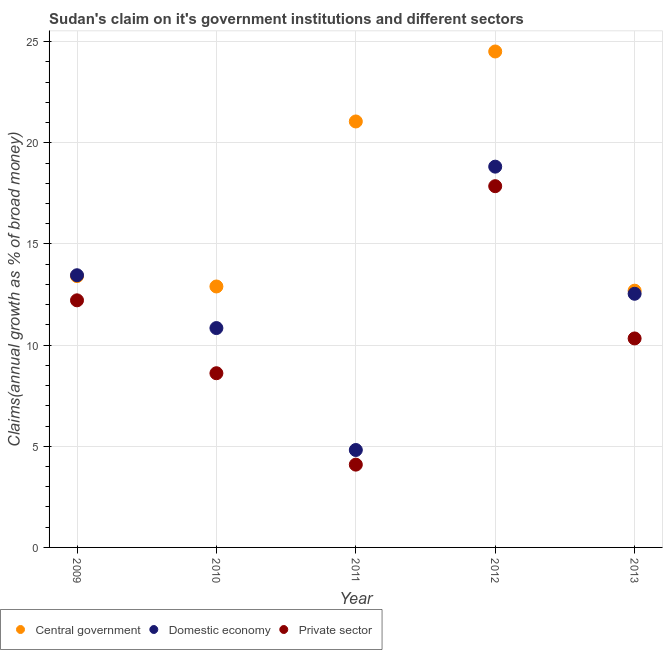Is the number of dotlines equal to the number of legend labels?
Your answer should be very brief. Yes. What is the percentage of claim on the central government in 2010?
Offer a very short reply. 12.9. Across all years, what is the maximum percentage of claim on the central government?
Ensure brevity in your answer.  24.51. Across all years, what is the minimum percentage of claim on the private sector?
Provide a succinct answer. 4.09. In which year was the percentage of claim on the central government minimum?
Your answer should be compact. 2013. What is the total percentage of claim on the private sector in the graph?
Your answer should be compact. 53.1. What is the difference between the percentage of claim on the private sector in 2009 and that in 2013?
Your answer should be very brief. 1.88. What is the difference between the percentage of claim on the central government in 2013 and the percentage of claim on the private sector in 2009?
Offer a very short reply. 0.48. What is the average percentage of claim on the private sector per year?
Offer a very short reply. 10.62. In the year 2013, what is the difference between the percentage of claim on the central government and percentage of claim on the domestic economy?
Keep it short and to the point. 0.15. What is the ratio of the percentage of claim on the central government in 2012 to that in 2013?
Ensure brevity in your answer.  1.93. Is the percentage of claim on the central government in 2009 less than that in 2012?
Ensure brevity in your answer.  Yes. Is the difference between the percentage of claim on the central government in 2010 and 2013 greater than the difference between the percentage of claim on the domestic economy in 2010 and 2013?
Offer a very short reply. Yes. What is the difference between the highest and the second highest percentage of claim on the domestic economy?
Your answer should be very brief. 5.37. What is the difference between the highest and the lowest percentage of claim on the central government?
Provide a succinct answer. 11.82. Is the sum of the percentage of claim on the central government in 2012 and 2013 greater than the maximum percentage of claim on the domestic economy across all years?
Your response must be concise. Yes. Is it the case that in every year, the sum of the percentage of claim on the central government and percentage of claim on the domestic economy is greater than the percentage of claim on the private sector?
Your answer should be compact. Yes. Does the percentage of claim on the domestic economy monotonically increase over the years?
Your answer should be very brief. No. Is the percentage of claim on the private sector strictly less than the percentage of claim on the domestic economy over the years?
Your answer should be compact. Yes. How many years are there in the graph?
Your answer should be compact. 5. What is the difference between two consecutive major ticks on the Y-axis?
Give a very brief answer. 5. Does the graph contain any zero values?
Your answer should be very brief. No. How are the legend labels stacked?
Make the answer very short. Horizontal. What is the title of the graph?
Your answer should be compact. Sudan's claim on it's government institutions and different sectors. What is the label or title of the Y-axis?
Offer a terse response. Claims(annual growth as % of broad money). What is the Claims(annual growth as % of broad money) of Central government in 2009?
Provide a short and direct response. 13.41. What is the Claims(annual growth as % of broad money) in Domestic economy in 2009?
Offer a very short reply. 13.45. What is the Claims(annual growth as % of broad money) of Private sector in 2009?
Ensure brevity in your answer.  12.21. What is the Claims(annual growth as % of broad money) in Central government in 2010?
Provide a succinct answer. 12.9. What is the Claims(annual growth as % of broad money) in Domestic economy in 2010?
Your response must be concise. 10.84. What is the Claims(annual growth as % of broad money) of Private sector in 2010?
Keep it short and to the point. 8.61. What is the Claims(annual growth as % of broad money) in Central government in 2011?
Provide a short and direct response. 21.05. What is the Claims(annual growth as % of broad money) of Domestic economy in 2011?
Provide a succinct answer. 4.82. What is the Claims(annual growth as % of broad money) of Private sector in 2011?
Keep it short and to the point. 4.09. What is the Claims(annual growth as % of broad money) of Central government in 2012?
Provide a succinct answer. 24.51. What is the Claims(annual growth as % of broad money) of Domestic economy in 2012?
Offer a very short reply. 18.82. What is the Claims(annual growth as % of broad money) of Private sector in 2012?
Your answer should be very brief. 17.85. What is the Claims(annual growth as % of broad money) of Central government in 2013?
Offer a terse response. 12.69. What is the Claims(annual growth as % of broad money) in Domestic economy in 2013?
Your answer should be compact. 12.54. What is the Claims(annual growth as % of broad money) of Private sector in 2013?
Provide a short and direct response. 10.33. Across all years, what is the maximum Claims(annual growth as % of broad money) of Central government?
Offer a terse response. 24.51. Across all years, what is the maximum Claims(annual growth as % of broad money) of Domestic economy?
Keep it short and to the point. 18.82. Across all years, what is the maximum Claims(annual growth as % of broad money) in Private sector?
Your answer should be compact. 17.85. Across all years, what is the minimum Claims(annual growth as % of broad money) of Central government?
Keep it short and to the point. 12.69. Across all years, what is the minimum Claims(annual growth as % of broad money) in Domestic economy?
Offer a terse response. 4.82. Across all years, what is the minimum Claims(annual growth as % of broad money) in Private sector?
Give a very brief answer. 4.09. What is the total Claims(annual growth as % of broad money) of Central government in the graph?
Ensure brevity in your answer.  84.56. What is the total Claims(annual growth as % of broad money) in Domestic economy in the graph?
Your answer should be compact. 60.47. What is the total Claims(annual growth as % of broad money) in Private sector in the graph?
Provide a succinct answer. 53.1. What is the difference between the Claims(annual growth as % of broad money) in Central government in 2009 and that in 2010?
Ensure brevity in your answer.  0.51. What is the difference between the Claims(annual growth as % of broad money) of Domestic economy in 2009 and that in 2010?
Keep it short and to the point. 2.61. What is the difference between the Claims(annual growth as % of broad money) in Private sector in 2009 and that in 2010?
Ensure brevity in your answer.  3.6. What is the difference between the Claims(annual growth as % of broad money) in Central government in 2009 and that in 2011?
Ensure brevity in your answer.  -7.64. What is the difference between the Claims(annual growth as % of broad money) in Domestic economy in 2009 and that in 2011?
Provide a succinct answer. 8.64. What is the difference between the Claims(annual growth as % of broad money) of Private sector in 2009 and that in 2011?
Provide a succinct answer. 8.12. What is the difference between the Claims(annual growth as % of broad money) of Central government in 2009 and that in 2012?
Make the answer very short. -11.1. What is the difference between the Claims(annual growth as % of broad money) in Domestic economy in 2009 and that in 2012?
Offer a very short reply. -5.37. What is the difference between the Claims(annual growth as % of broad money) of Private sector in 2009 and that in 2012?
Provide a succinct answer. -5.64. What is the difference between the Claims(annual growth as % of broad money) of Central government in 2009 and that in 2013?
Your response must be concise. 0.72. What is the difference between the Claims(annual growth as % of broad money) of Domestic economy in 2009 and that in 2013?
Offer a very short reply. 0.92. What is the difference between the Claims(annual growth as % of broad money) in Private sector in 2009 and that in 2013?
Provide a succinct answer. 1.88. What is the difference between the Claims(annual growth as % of broad money) in Central government in 2010 and that in 2011?
Keep it short and to the point. -8.16. What is the difference between the Claims(annual growth as % of broad money) of Domestic economy in 2010 and that in 2011?
Your response must be concise. 6.03. What is the difference between the Claims(annual growth as % of broad money) in Private sector in 2010 and that in 2011?
Give a very brief answer. 4.52. What is the difference between the Claims(annual growth as % of broad money) of Central government in 2010 and that in 2012?
Offer a very short reply. -11.61. What is the difference between the Claims(annual growth as % of broad money) of Domestic economy in 2010 and that in 2012?
Offer a very short reply. -7.98. What is the difference between the Claims(annual growth as % of broad money) in Private sector in 2010 and that in 2012?
Offer a terse response. -9.24. What is the difference between the Claims(annual growth as % of broad money) of Central government in 2010 and that in 2013?
Make the answer very short. 0.21. What is the difference between the Claims(annual growth as % of broad money) of Domestic economy in 2010 and that in 2013?
Your response must be concise. -1.69. What is the difference between the Claims(annual growth as % of broad money) in Private sector in 2010 and that in 2013?
Your answer should be compact. -1.72. What is the difference between the Claims(annual growth as % of broad money) in Central government in 2011 and that in 2012?
Provide a succinct answer. -3.46. What is the difference between the Claims(annual growth as % of broad money) in Domestic economy in 2011 and that in 2012?
Provide a short and direct response. -14. What is the difference between the Claims(annual growth as % of broad money) of Private sector in 2011 and that in 2012?
Your answer should be compact. -13.76. What is the difference between the Claims(annual growth as % of broad money) of Central government in 2011 and that in 2013?
Make the answer very short. 8.36. What is the difference between the Claims(annual growth as % of broad money) in Domestic economy in 2011 and that in 2013?
Your answer should be very brief. -7.72. What is the difference between the Claims(annual growth as % of broad money) in Private sector in 2011 and that in 2013?
Your response must be concise. -6.24. What is the difference between the Claims(annual growth as % of broad money) in Central government in 2012 and that in 2013?
Offer a terse response. 11.82. What is the difference between the Claims(annual growth as % of broad money) of Domestic economy in 2012 and that in 2013?
Your response must be concise. 6.28. What is the difference between the Claims(annual growth as % of broad money) in Private sector in 2012 and that in 2013?
Offer a terse response. 7.53. What is the difference between the Claims(annual growth as % of broad money) of Central government in 2009 and the Claims(annual growth as % of broad money) of Domestic economy in 2010?
Your response must be concise. 2.57. What is the difference between the Claims(annual growth as % of broad money) in Central government in 2009 and the Claims(annual growth as % of broad money) in Private sector in 2010?
Offer a terse response. 4.8. What is the difference between the Claims(annual growth as % of broad money) of Domestic economy in 2009 and the Claims(annual growth as % of broad money) of Private sector in 2010?
Make the answer very short. 4.84. What is the difference between the Claims(annual growth as % of broad money) of Central government in 2009 and the Claims(annual growth as % of broad money) of Domestic economy in 2011?
Ensure brevity in your answer.  8.59. What is the difference between the Claims(annual growth as % of broad money) in Central government in 2009 and the Claims(annual growth as % of broad money) in Private sector in 2011?
Provide a short and direct response. 9.32. What is the difference between the Claims(annual growth as % of broad money) in Domestic economy in 2009 and the Claims(annual growth as % of broad money) in Private sector in 2011?
Provide a succinct answer. 9.36. What is the difference between the Claims(annual growth as % of broad money) of Central government in 2009 and the Claims(annual growth as % of broad money) of Domestic economy in 2012?
Your answer should be compact. -5.41. What is the difference between the Claims(annual growth as % of broad money) in Central government in 2009 and the Claims(annual growth as % of broad money) in Private sector in 2012?
Make the answer very short. -4.45. What is the difference between the Claims(annual growth as % of broad money) in Domestic economy in 2009 and the Claims(annual growth as % of broad money) in Private sector in 2012?
Make the answer very short. -4.4. What is the difference between the Claims(annual growth as % of broad money) of Central government in 2009 and the Claims(annual growth as % of broad money) of Domestic economy in 2013?
Offer a very short reply. 0.87. What is the difference between the Claims(annual growth as % of broad money) in Central government in 2009 and the Claims(annual growth as % of broad money) in Private sector in 2013?
Offer a very short reply. 3.08. What is the difference between the Claims(annual growth as % of broad money) in Domestic economy in 2009 and the Claims(annual growth as % of broad money) in Private sector in 2013?
Provide a succinct answer. 3.12. What is the difference between the Claims(annual growth as % of broad money) of Central government in 2010 and the Claims(annual growth as % of broad money) of Domestic economy in 2011?
Give a very brief answer. 8.08. What is the difference between the Claims(annual growth as % of broad money) of Central government in 2010 and the Claims(annual growth as % of broad money) of Private sector in 2011?
Your answer should be very brief. 8.81. What is the difference between the Claims(annual growth as % of broad money) in Domestic economy in 2010 and the Claims(annual growth as % of broad money) in Private sector in 2011?
Give a very brief answer. 6.75. What is the difference between the Claims(annual growth as % of broad money) in Central government in 2010 and the Claims(annual growth as % of broad money) in Domestic economy in 2012?
Your answer should be compact. -5.92. What is the difference between the Claims(annual growth as % of broad money) in Central government in 2010 and the Claims(annual growth as % of broad money) in Private sector in 2012?
Your answer should be compact. -4.96. What is the difference between the Claims(annual growth as % of broad money) in Domestic economy in 2010 and the Claims(annual growth as % of broad money) in Private sector in 2012?
Ensure brevity in your answer.  -7.01. What is the difference between the Claims(annual growth as % of broad money) in Central government in 2010 and the Claims(annual growth as % of broad money) in Domestic economy in 2013?
Keep it short and to the point. 0.36. What is the difference between the Claims(annual growth as % of broad money) in Central government in 2010 and the Claims(annual growth as % of broad money) in Private sector in 2013?
Ensure brevity in your answer.  2.57. What is the difference between the Claims(annual growth as % of broad money) of Domestic economy in 2010 and the Claims(annual growth as % of broad money) of Private sector in 2013?
Your answer should be compact. 0.51. What is the difference between the Claims(annual growth as % of broad money) in Central government in 2011 and the Claims(annual growth as % of broad money) in Domestic economy in 2012?
Your answer should be compact. 2.23. What is the difference between the Claims(annual growth as % of broad money) in Central government in 2011 and the Claims(annual growth as % of broad money) in Private sector in 2012?
Your response must be concise. 3.2. What is the difference between the Claims(annual growth as % of broad money) of Domestic economy in 2011 and the Claims(annual growth as % of broad money) of Private sector in 2012?
Offer a very short reply. -13.04. What is the difference between the Claims(annual growth as % of broad money) in Central government in 2011 and the Claims(annual growth as % of broad money) in Domestic economy in 2013?
Provide a succinct answer. 8.52. What is the difference between the Claims(annual growth as % of broad money) of Central government in 2011 and the Claims(annual growth as % of broad money) of Private sector in 2013?
Your answer should be very brief. 10.72. What is the difference between the Claims(annual growth as % of broad money) in Domestic economy in 2011 and the Claims(annual growth as % of broad money) in Private sector in 2013?
Ensure brevity in your answer.  -5.51. What is the difference between the Claims(annual growth as % of broad money) of Central government in 2012 and the Claims(annual growth as % of broad money) of Domestic economy in 2013?
Your answer should be very brief. 11.98. What is the difference between the Claims(annual growth as % of broad money) in Central government in 2012 and the Claims(annual growth as % of broad money) in Private sector in 2013?
Provide a short and direct response. 14.18. What is the difference between the Claims(annual growth as % of broad money) of Domestic economy in 2012 and the Claims(annual growth as % of broad money) of Private sector in 2013?
Offer a terse response. 8.49. What is the average Claims(annual growth as % of broad money) of Central government per year?
Your answer should be compact. 16.91. What is the average Claims(annual growth as % of broad money) in Domestic economy per year?
Offer a terse response. 12.09. What is the average Claims(annual growth as % of broad money) in Private sector per year?
Give a very brief answer. 10.62. In the year 2009, what is the difference between the Claims(annual growth as % of broad money) of Central government and Claims(annual growth as % of broad money) of Domestic economy?
Offer a terse response. -0.04. In the year 2009, what is the difference between the Claims(annual growth as % of broad money) in Central government and Claims(annual growth as % of broad money) in Private sector?
Offer a very short reply. 1.2. In the year 2009, what is the difference between the Claims(annual growth as % of broad money) of Domestic economy and Claims(annual growth as % of broad money) of Private sector?
Offer a terse response. 1.24. In the year 2010, what is the difference between the Claims(annual growth as % of broad money) in Central government and Claims(annual growth as % of broad money) in Domestic economy?
Keep it short and to the point. 2.06. In the year 2010, what is the difference between the Claims(annual growth as % of broad money) in Central government and Claims(annual growth as % of broad money) in Private sector?
Keep it short and to the point. 4.29. In the year 2010, what is the difference between the Claims(annual growth as % of broad money) in Domestic economy and Claims(annual growth as % of broad money) in Private sector?
Keep it short and to the point. 2.23. In the year 2011, what is the difference between the Claims(annual growth as % of broad money) of Central government and Claims(annual growth as % of broad money) of Domestic economy?
Your answer should be very brief. 16.24. In the year 2011, what is the difference between the Claims(annual growth as % of broad money) in Central government and Claims(annual growth as % of broad money) in Private sector?
Ensure brevity in your answer.  16.96. In the year 2011, what is the difference between the Claims(annual growth as % of broad money) of Domestic economy and Claims(annual growth as % of broad money) of Private sector?
Offer a terse response. 0.72. In the year 2012, what is the difference between the Claims(annual growth as % of broad money) of Central government and Claims(annual growth as % of broad money) of Domestic economy?
Give a very brief answer. 5.69. In the year 2012, what is the difference between the Claims(annual growth as % of broad money) in Central government and Claims(annual growth as % of broad money) in Private sector?
Give a very brief answer. 6.66. In the year 2012, what is the difference between the Claims(annual growth as % of broad money) in Domestic economy and Claims(annual growth as % of broad money) in Private sector?
Your response must be concise. 0.97. In the year 2013, what is the difference between the Claims(annual growth as % of broad money) of Central government and Claims(annual growth as % of broad money) of Domestic economy?
Ensure brevity in your answer.  0.15. In the year 2013, what is the difference between the Claims(annual growth as % of broad money) in Central government and Claims(annual growth as % of broad money) in Private sector?
Make the answer very short. 2.36. In the year 2013, what is the difference between the Claims(annual growth as % of broad money) of Domestic economy and Claims(annual growth as % of broad money) of Private sector?
Your response must be concise. 2.21. What is the ratio of the Claims(annual growth as % of broad money) of Central government in 2009 to that in 2010?
Your response must be concise. 1.04. What is the ratio of the Claims(annual growth as % of broad money) of Domestic economy in 2009 to that in 2010?
Your response must be concise. 1.24. What is the ratio of the Claims(annual growth as % of broad money) in Private sector in 2009 to that in 2010?
Offer a very short reply. 1.42. What is the ratio of the Claims(annual growth as % of broad money) of Central government in 2009 to that in 2011?
Your answer should be compact. 0.64. What is the ratio of the Claims(annual growth as % of broad money) in Domestic economy in 2009 to that in 2011?
Ensure brevity in your answer.  2.79. What is the ratio of the Claims(annual growth as % of broad money) in Private sector in 2009 to that in 2011?
Offer a very short reply. 2.98. What is the ratio of the Claims(annual growth as % of broad money) in Central government in 2009 to that in 2012?
Provide a succinct answer. 0.55. What is the ratio of the Claims(annual growth as % of broad money) in Domestic economy in 2009 to that in 2012?
Provide a succinct answer. 0.71. What is the ratio of the Claims(annual growth as % of broad money) in Private sector in 2009 to that in 2012?
Make the answer very short. 0.68. What is the ratio of the Claims(annual growth as % of broad money) in Central government in 2009 to that in 2013?
Provide a short and direct response. 1.06. What is the ratio of the Claims(annual growth as % of broad money) in Domestic economy in 2009 to that in 2013?
Your answer should be very brief. 1.07. What is the ratio of the Claims(annual growth as % of broad money) in Private sector in 2009 to that in 2013?
Your answer should be very brief. 1.18. What is the ratio of the Claims(annual growth as % of broad money) of Central government in 2010 to that in 2011?
Your response must be concise. 0.61. What is the ratio of the Claims(annual growth as % of broad money) in Domestic economy in 2010 to that in 2011?
Make the answer very short. 2.25. What is the ratio of the Claims(annual growth as % of broad money) of Private sector in 2010 to that in 2011?
Provide a short and direct response. 2.1. What is the ratio of the Claims(annual growth as % of broad money) of Central government in 2010 to that in 2012?
Provide a succinct answer. 0.53. What is the ratio of the Claims(annual growth as % of broad money) of Domestic economy in 2010 to that in 2012?
Your answer should be compact. 0.58. What is the ratio of the Claims(annual growth as % of broad money) of Private sector in 2010 to that in 2012?
Make the answer very short. 0.48. What is the ratio of the Claims(annual growth as % of broad money) in Central government in 2010 to that in 2013?
Give a very brief answer. 1.02. What is the ratio of the Claims(annual growth as % of broad money) in Domestic economy in 2010 to that in 2013?
Give a very brief answer. 0.86. What is the ratio of the Claims(annual growth as % of broad money) of Private sector in 2010 to that in 2013?
Keep it short and to the point. 0.83. What is the ratio of the Claims(annual growth as % of broad money) of Central government in 2011 to that in 2012?
Give a very brief answer. 0.86. What is the ratio of the Claims(annual growth as % of broad money) of Domestic economy in 2011 to that in 2012?
Your response must be concise. 0.26. What is the ratio of the Claims(annual growth as % of broad money) of Private sector in 2011 to that in 2012?
Offer a terse response. 0.23. What is the ratio of the Claims(annual growth as % of broad money) of Central government in 2011 to that in 2013?
Keep it short and to the point. 1.66. What is the ratio of the Claims(annual growth as % of broad money) of Domestic economy in 2011 to that in 2013?
Offer a terse response. 0.38. What is the ratio of the Claims(annual growth as % of broad money) of Private sector in 2011 to that in 2013?
Ensure brevity in your answer.  0.4. What is the ratio of the Claims(annual growth as % of broad money) in Central government in 2012 to that in 2013?
Your response must be concise. 1.93. What is the ratio of the Claims(annual growth as % of broad money) of Domestic economy in 2012 to that in 2013?
Your response must be concise. 1.5. What is the ratio of the Claims(annual growth as % of broad money) of Private sector in 2012 to that in 2013?
Your answer should be very brief. 1.73. What is the difference between the highest and the second highest Claims(annual growth as % of broad money) of Central government?
Your answer should be compact. 3.46. What is the difference between the highest and the second highest Claims(annual growth as % of broad money) of Domestic economy?
Give a very brief answer. 5.37. What is the difference between the highest and the second highest Claims(annual growth as % of broad money) in Private sector?
Offer a very short reply. 5.64. What is the difference between the highest and the lowest Claims(annual growth as % of broad money) of Central government?
Your answer should be compact. 11.82. What is the difference between the highest and the lowest Claims(annual growth as % of broad money) of Domestic economy?
Provide a succinct answer. 14. What is the difference between the highest and the lowest Claims(annual growth as % of broad money) in Private sector?
Give a very brief answer. 13.76. 